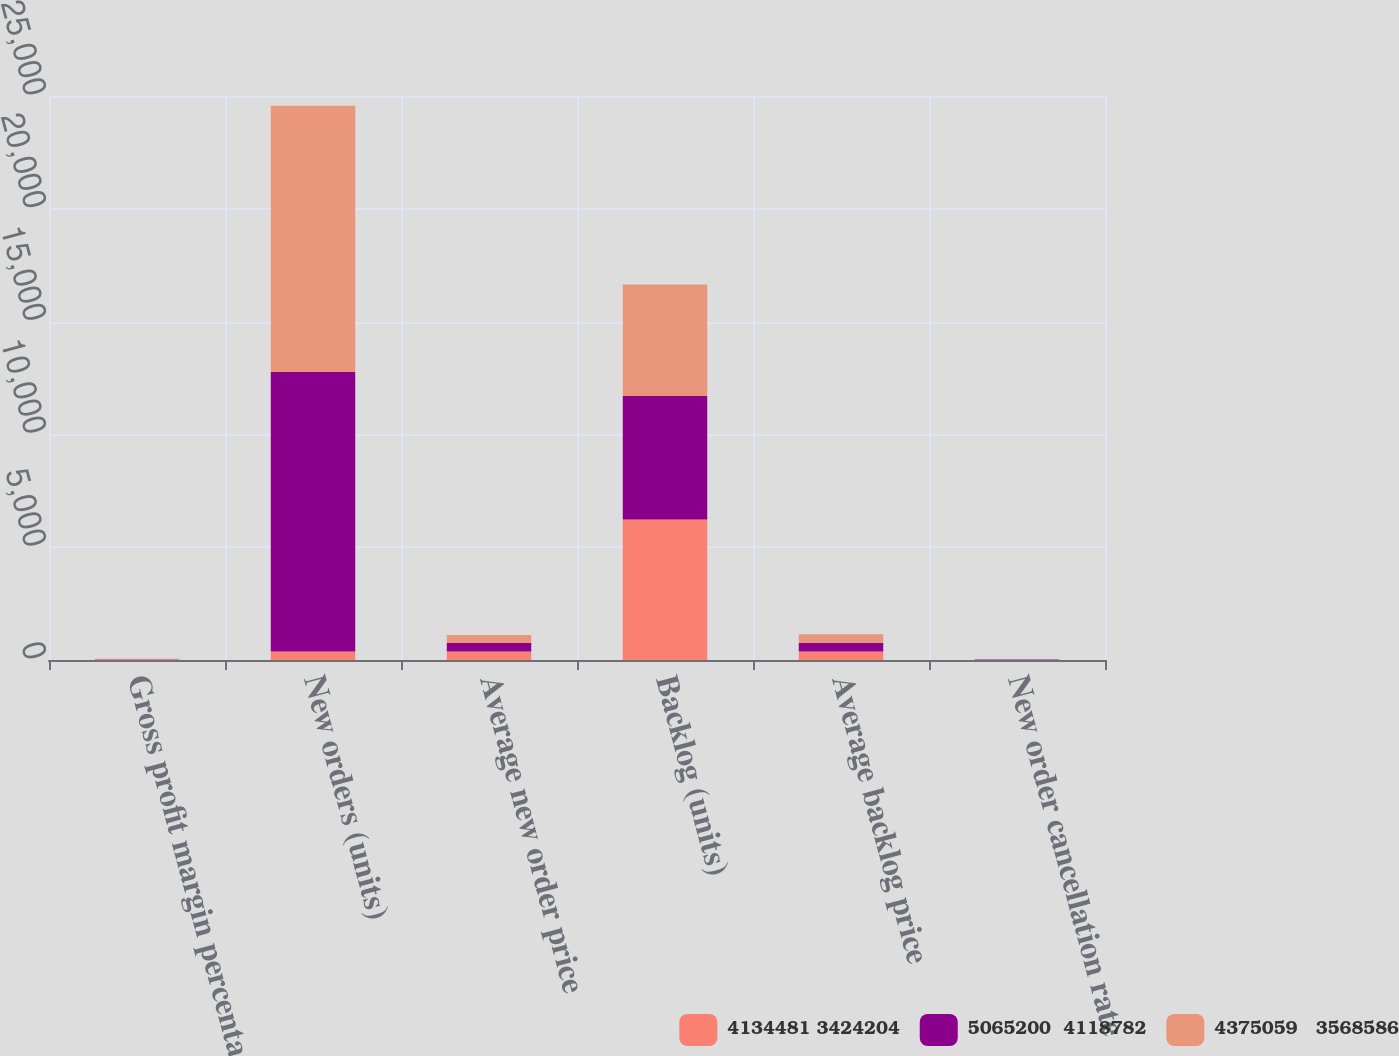Convert chart to OTSL. <chart><loc_0><loc_0><loc_500><loc_500><stacked_bar_chart><ecel><fcel>Gross profit margin percentage<fcel>New orders (units)<fcel>Average new order price<fcel>Backlog (units)<fcel>Average backlog price<fcel>New order cancellation rate<nl><fcel>4134481 3424204<fcel>18.7<fcel>373.7<fcel>378.7<fcel>6229<fcel>381.3<fcel>14.5<nl><fcel>5065200  4118782<fcel>18.4<fcel>12389<fcel>373.7<fcel>5475<fcel>384.6<fcel>14.6<nl><fcel>4375059   3568586<fcel>17.2<fcel>11800<fcel>360.4<fcel>4945<fcel>373.2<fcel>14.9<nl></chart> 